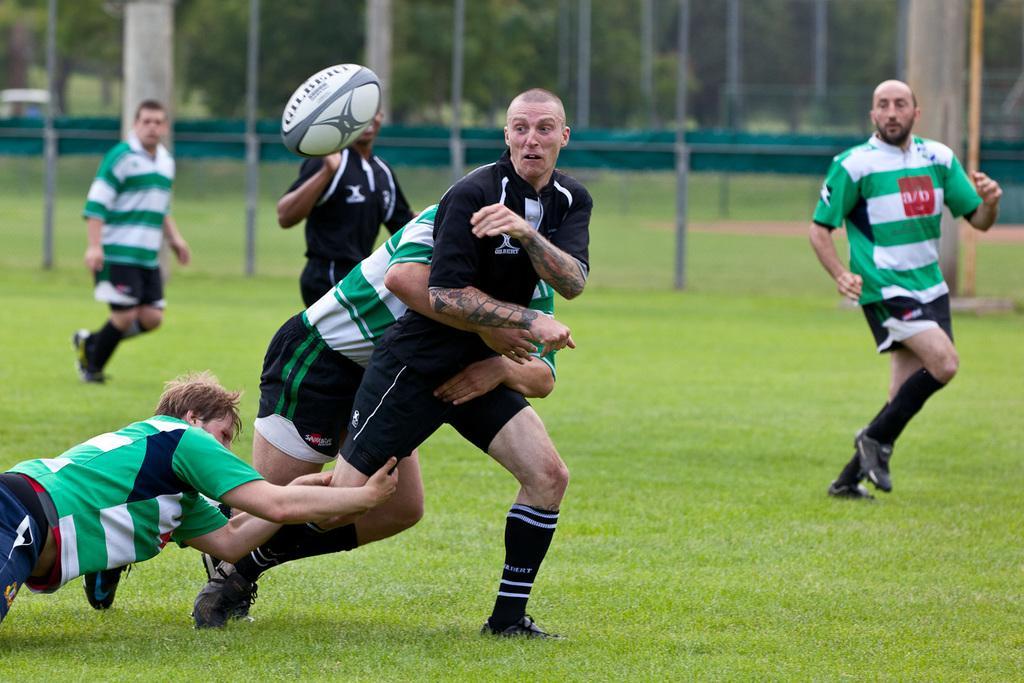In one or two sentences, can you explain what this image depicts? This is a playing ground. Here I can see few men wearing t-shirts, shorts and playing a game. They are running towards the right side and two men are holding one person. Here I can see the ball. In the background there are few poles and trees. On the ground, I can see the grass. 